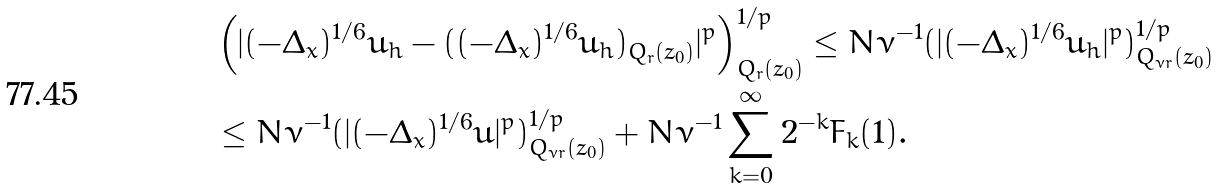<formula> <loc_0><loc_0><loc_500><loc_500>& \left ( | ( - \Delta _ { x } ) ^ { 1 / 6 } u _ { h } - ( ( - \Delta _ { x } ) ^ { 1 / 6 } u _ { h } ) _ { Q _ { r } ( z _ { 0 } ) } | ^ { p } \right ) ^ { 1 / p } _ { Q _ { r } ( z _ { 0 } ) } \leq N \nu ^ { - 1 } ( | ( - \Delta _ { x } ) ^ { 1 / 6 } u _ { h } | ^ { p } ) ^ { 1 / p } _ { Q _ { \nu r } ( z _ { 0 } ) } \\ & \leq N \nu ^ { - 1 } ( | ( - \Delta _ { x } ) ^ { 1 / 6 } u | ^ { p } ) ^ { 1 / p } _ { Q _ { \nu r } ( z _ { 0 } ) } + N \nu ^ { - 1 } \sum _ { k = 0 } ^ { \infty } 2 ^ { - k } F _ { k } ( 1 ) .</formula> 